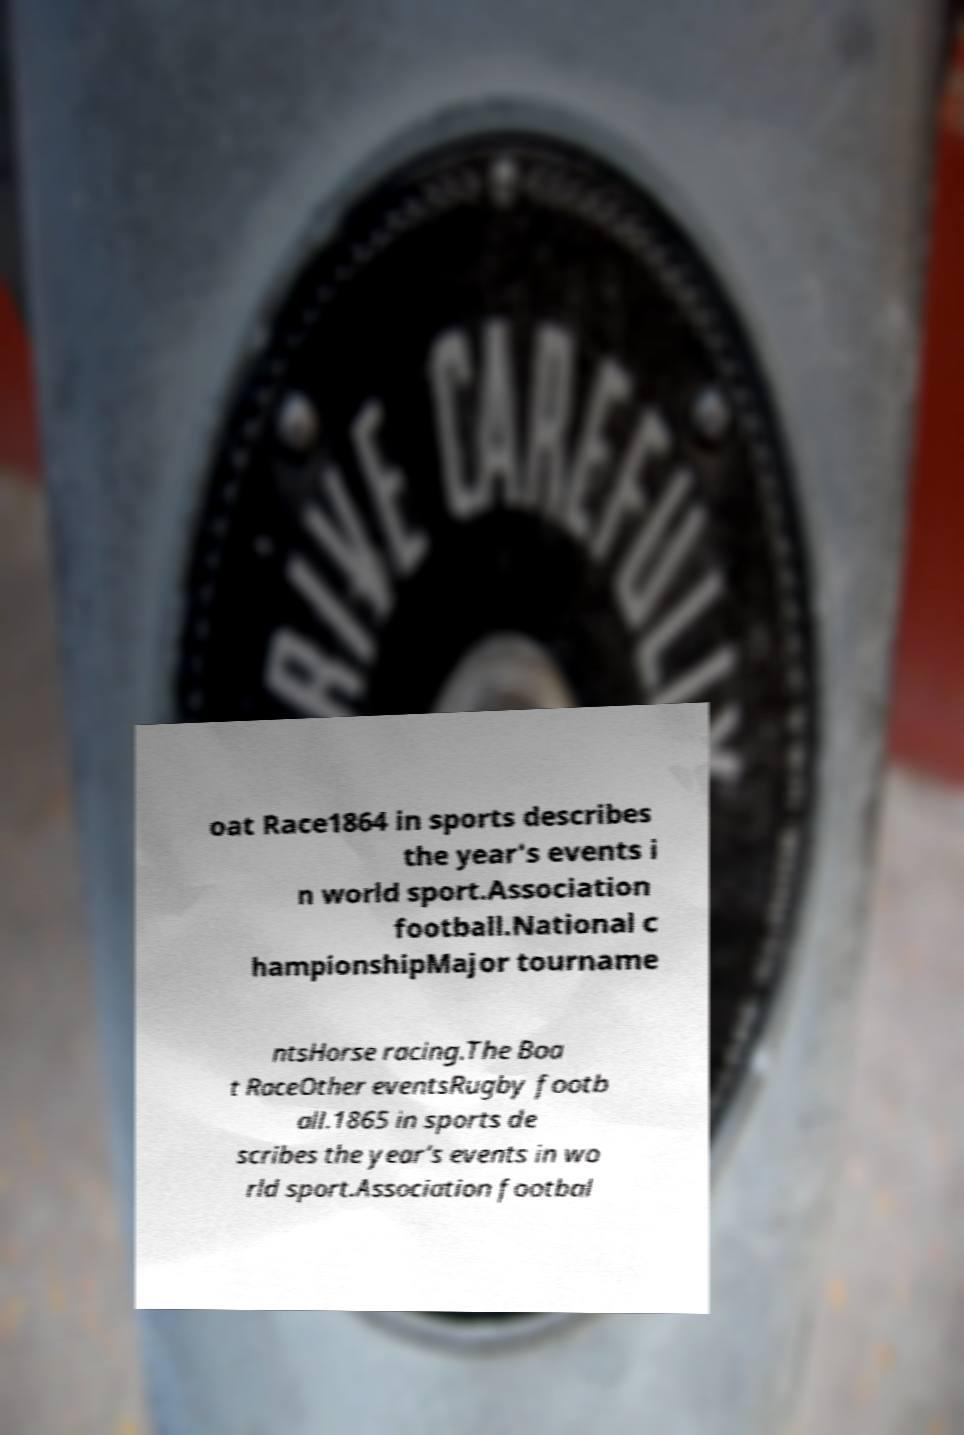Can you read and provide the text displayed in the image?This photo seems to have some interesting text. Can you extract and type it out for me? oat Race1864 in sports describes the year's events i n world sport.Association football.National c hampionshipMajor tourname ntsHorse racing.The Boa t RaceOther eventsRugby footb all.1865 in sports de scribes the year's events in wo rld sport.Association footbal 